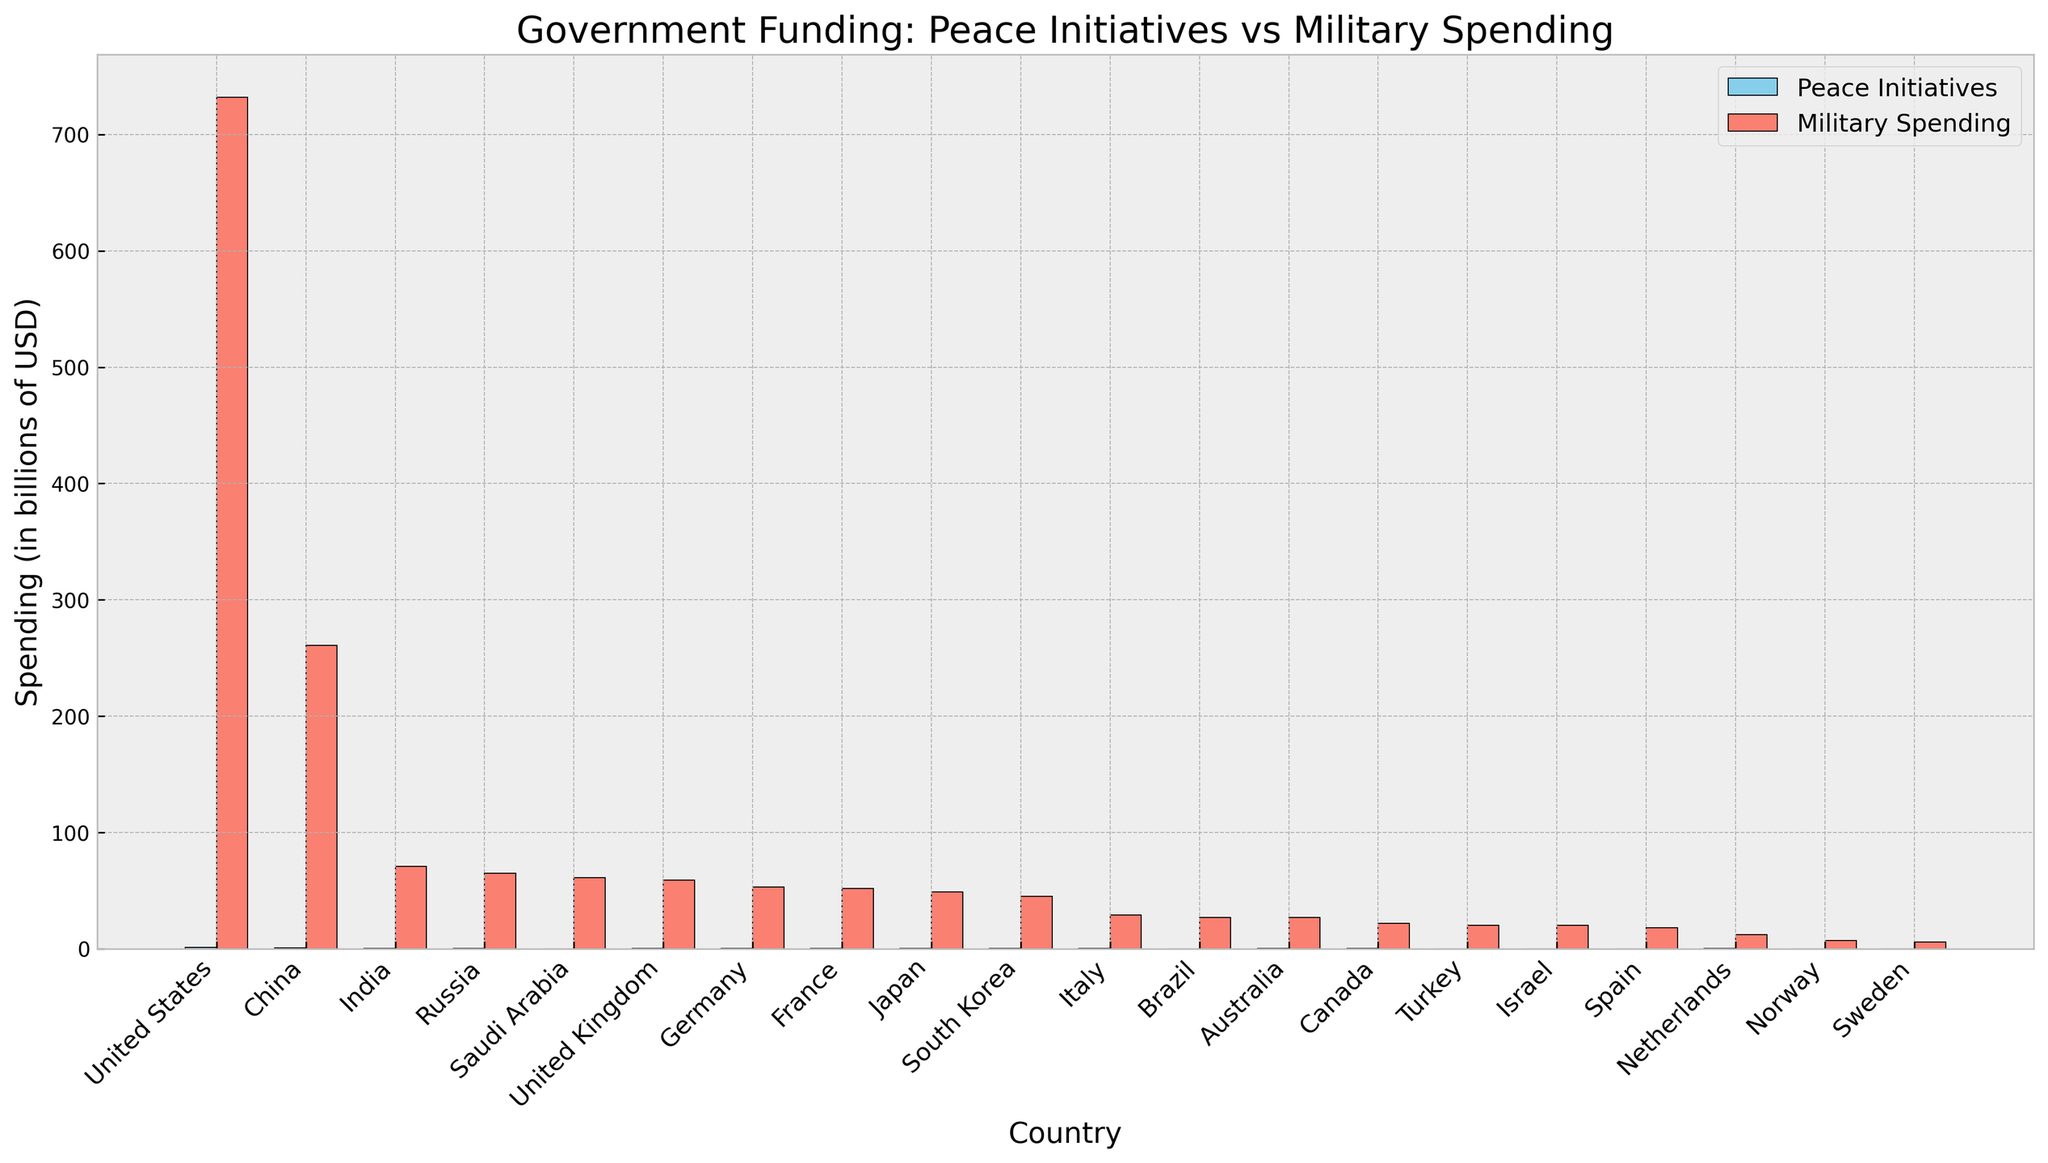Which country has the highest military spending in the dataset? By observing the heights of the red (Military Spending) bars, we can see that the United States has the highest military spending.
Answer: United States Which pair of countries have the smallest difference between their spending on peace initiatives and military spending? To find this, we need to compare the differences in the heights of blue (Peace Initiatives) and red (Military Spending) bars. Norway and Sweden have the smallest differences as both have nearly similar heights.
Answer: Norway and Sweden How much more does China spend on military compared to peace initiatives? Look at the red (Military Spending) and blue (Peace Initiatives) bars for China. The military spending is 261 billion, and peace initiatives are 0.8 billion. The difference is 261 - 0.8 = 260.2 billion.
Answer: 260.2 billion Of the countries listed, which has the smallest allocation for peace initiatives? By comparing the heights of the blue bars, Israel has the smallest allocation for peace initiatives.
Answer: Israel Rank the top three countries based on their spending on peace initiatives. Rank the countries by observing the heights of the blue bars. The top three are the United States (1.2 billion), China (0.8 billion), and Russia (0.5 billion).
Answer: United States, China, Russia Which country has a nearly equal allocation for both peace initiatives and military spending? By observing the figure, no country has nearly equal allocations for both categories. However, looking for the smallest relative differences, we see that Sweden’s spending on peace initiatives and military spending are the closest.
Answer: Sweden What is the ratio of military spending to peace initiatives for India? For India, the spending is 71 billion on the military and 0.3 billion on peace initiatives. The ratio is 71 / 0.3 = 236.67.
Answer: 236.67 Which country has the highest peace initiative spending compared to its military spending? To find this, divide the peace initiative spending by military spending for each country and identify the highest ratio. The United States has a ratio of 1.2 / 732 = 0.00164, but further visual comparison indicates Canada’s 0.25 / 22 = 0.0114 is notably higher.
Answer: Canada 